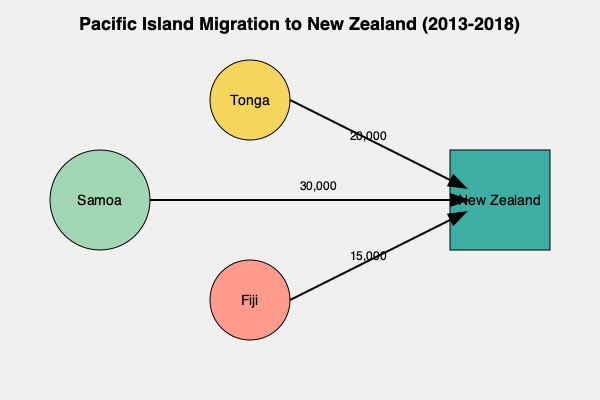Based on the flow chart depicting Pacific Island migration to New Zealand between 2013 and 2018, which country had the highest number of migrants, and what percentage did they represent of the total migration from the three shown islands? To answer this question, we need to follow these steps:

1. Identify the migration numbers for each country:
   - Samoa: 30,000
   - Tonga: 20,000
   - Fiji: 15,000

2. Determine which country had the highest number of migrants:
   Samoa had the highest with 30,000 migrants.

3. Calculate the total migration from all three islands:
   $30,000 + 20,000 + 15,000 = 65,000$ total migrants

4. Calculate the percentage of migrants from Samoa:
   $\frac{\text{Samoan migrants}}{\text{Total migrants}} \times 100\%$
   $\frac{30,000}{65,000} \times 100\% = 0.4615 \times 100\% = 46.15\%$

Therefore, Samoa had the highest number of migrants, representing 46.15% of the total migration from the three shown islands.
Answer: Samoa, 46.15% 